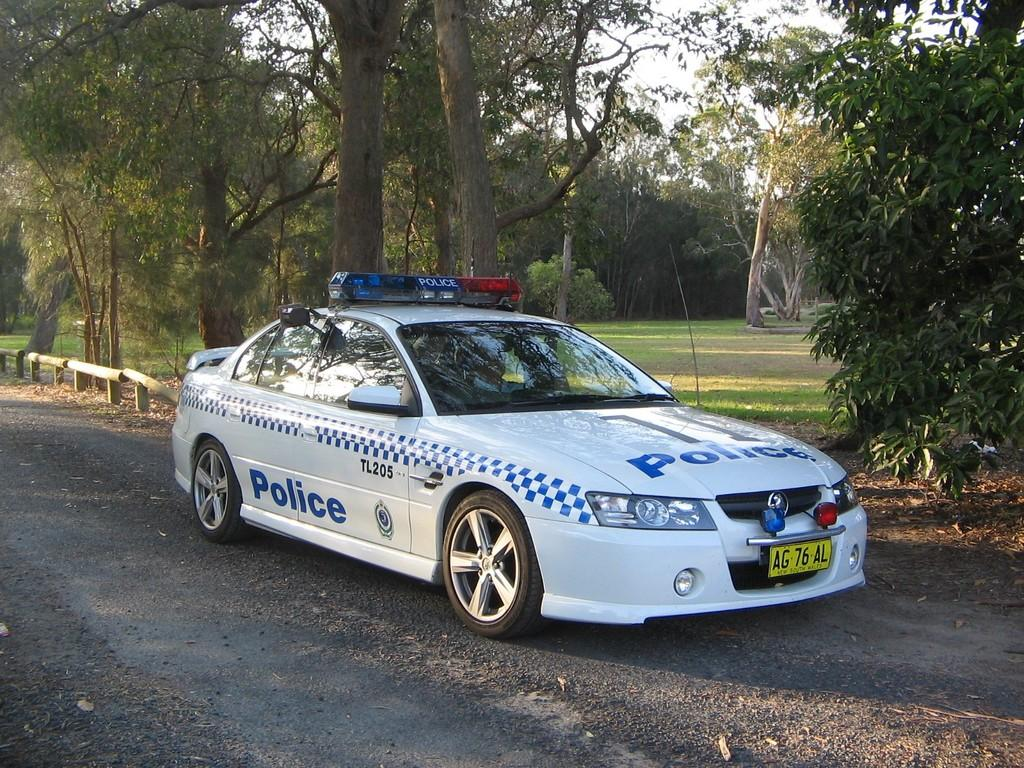What is the main subject of the image? There is a vehicle on the road in the image. What is located next to the vehicle? There is a fence next to the vehicle. What type of natural environment can be seen in the image? There are many trees visible in the image. What is visible in the background of the image? The sky is visible in the background of the image. Can you tell me how many frogs are sitting on the vehicle in the image? There are no frogs present on the vehicle in the image. What type of farming equipment can be seen in the image? There is no farming equipment visible in the image; it features a vehicle on the road with a fence and trees in the background. 